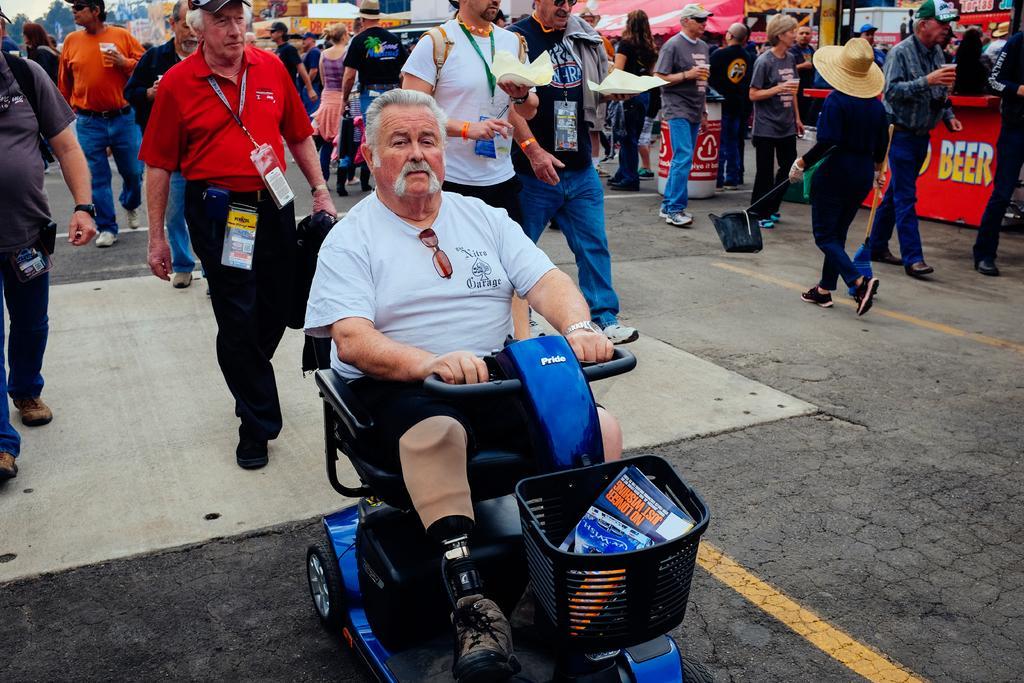How would you summarize this image in a sentence or two? The old man in the middle of the picture wearing white T-shirt is sitting on the bike scooter. Behind him, we see people walking on the road. On the right corner of the picture, we see a red color board with some text written on it. We see a tent in red color and we even see a garbage bin. There are many trees, buildings and shops in the background. This picture is clicked outside the city. 